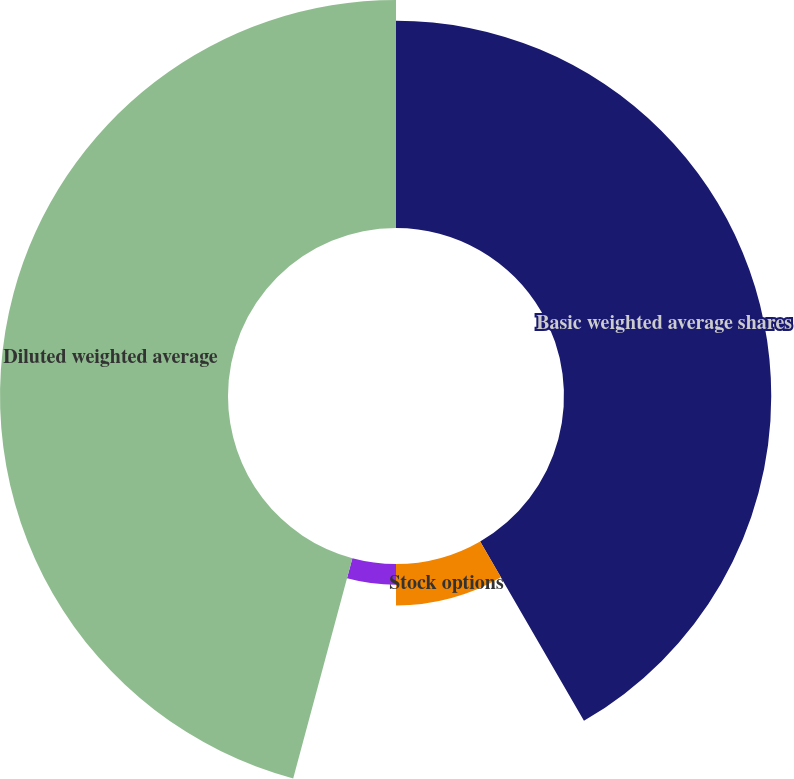Convert chart. <chart><loc_0><loc_0><loc_500><loc_500><pie_chart><fcel>Basic weighted average shares<fcel>Stock options<fcel>Restricted stock units<fcel>Employee stock purchase plan<fcel>Diluted weighted average<nl><fcel>41.65%<fcel>8.35%<fcel>4.18%<fcel>0.0%<fcel>45.82%<nl></chart> 